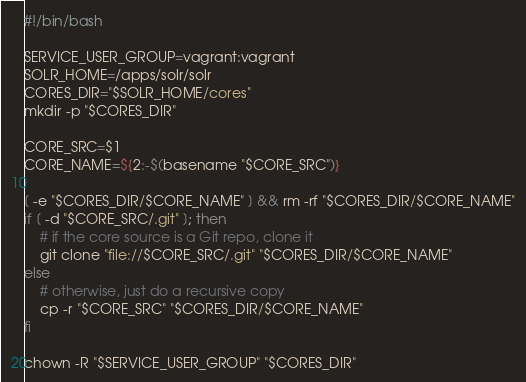Convert code to text. <code><loc_0><loc_0><loc_500><loc_500><_Bash_>#!/bin/bash

SERVICE_USER_GROUP=vagrant:vagrant
SOLR_HOME=/apps/solr/solr
CORES_DIR="$SOLR_HOME/cores"
mkdir -p "$CORES_DIR"

CORE_SRC=$1
CORE_NAME=${2:-$(basename "$CORE_SRC")}

[ -e "$CORES_DIR/$CORE_NAME" ] && rm -rf "$CORES_DIR/$CORE_NAME"
if [ -d "$CORE_SRC/.git" ]; then
    # if the core source is a Git repo, clone it
    git clone "file://$CORE_SRC/.git" "$CORES_DIR/$CORE_NAME"
else
    # otherwise, just do a recursive copy
    cp -r "$CORE_SRC" "$CORES_DIR/$CORE_NAME"
fi

chown -R "$SERVICE_USER_GROUP" "$CORES_DIR"
</code> 